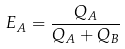Convert formula to latex. <formula><loc_0><loc_0><loc_500><loc_500>E _ { A } = \frac { Q _ { A } } { Q _ { A } + Q _ { B } }</formula> 